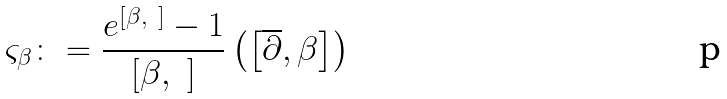Convert formula to latex. <formula><loc_0><loc_0><loc_500><loc_500>\varsigma _ { \beta } \colon = \frac { e ^ { \left [ \beta , \ \right ] } - 1 } { \left [ \beta , \ \right ] } \left ( \left [ \overline { \partial } , \beta \right ] \right )</formula> 